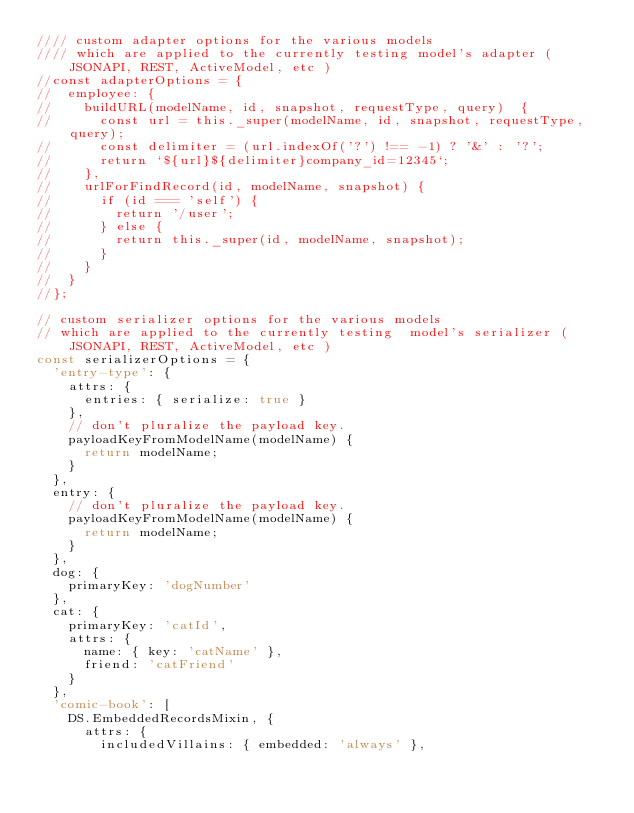Convert code to text. <code><loc_0><loc_0><loc_500><loc_500><_JavaScript_>//// custom adapter options for the various models
//// which are applied to the currently testing model's adapter ( JSONAPI, REST, ActiveModel, etc )
//const adapterOptions = {
//  employee: {
//    buildURL(modelName, id, snapshot, requestType, query)  {
//      const url = this._super(modelName, id, snapshot, requestType, query);
//      const delimiter = (url.indexOf('?') !== -1) ? '&' : '?';
//      return `${url}${delimiter}company_id=12345`;
//    },
//    urlForFindRecord(id, modelName, snapshot) {
//      if (id === 'self') {
//        return '/user';
//      } else {
//        return this._super(id, modelName, snapshot);
//      }
//    }
//  }
//};

// custom serializer options for the various models 
// which are applied to the currently testing  model's serializer ( JSONAPI, REST, ActiveModel, etc )
const serializerOptions = {
  'entry-type': {
    attrs: {
      entries: { serialize: true }
    },
    // don't pluralize the payload key.
    payloadKeyFromModelName(modelName) {
      return modelName;
    }
  },
  entry: {
    // don't pluralize the payload key.
    payloadKeyFromModelName(modelName) {
      return modelName;
    }
  },
  dog: {
    primaryKey: 'dogNumber'
  },
  cat: {
    primaryKey: 'catId',
    attrs: {
      name: { key: 'catName' },
      friend: 'catFriend'
    }
  },
  'comic-book': [
    DS.EmbeddedRecordsMixin, {
      attrs: {
        includedVillains: { embedded: 'always' },</code> 